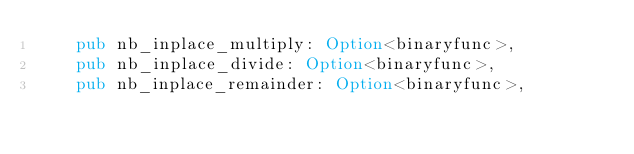<code> <loc_0><loc_0><loc_500><loc_500><_Rust_>    pub nb_inplace_multiply: Option<binaryfunc>,
    pub nb_inplace_divide: Option<binaryfunc>,
    pub nb_inplace_remainder: Option<binaryfunc>,</code> 